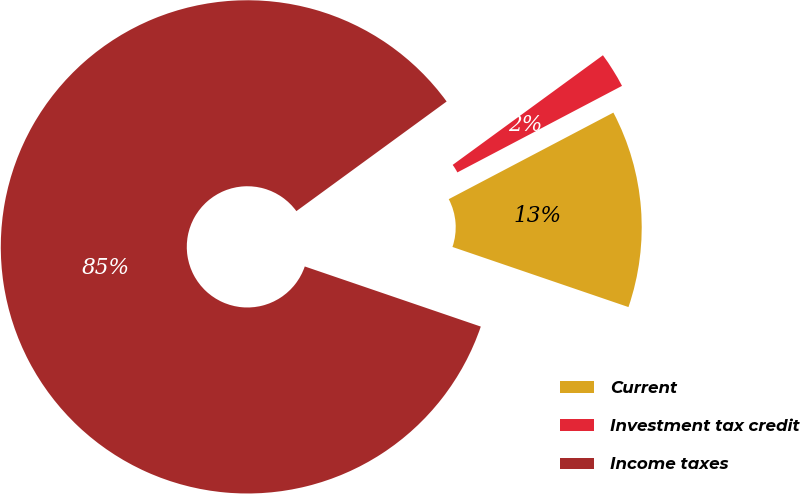Convert chart. <chart><loc_0><loc_0><loc_500><loc_500><pie_chart><fcel>Current<fcel>Investment tax credit<fcel>Income taxes<nl><fcel>12.94%<fcel>2.33%<fcel>84.72%<nl></chart> 